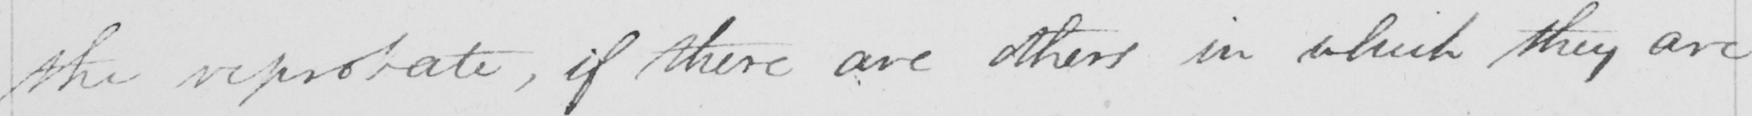Transcribe the text shown in this historical manuscript line. the reprobate , if there are others in which they are 